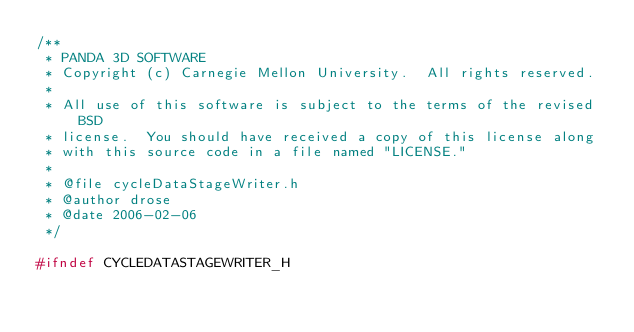<code> <loc_0><loc_0><loc_500><loc_500><_C_>/**
 * PANDA 3D SOFTWARE
 * Copyright (c) Carnegie Mellon University.  All rights reserved.
 *
 * All use of this software is subject to the terms of the revised BSD
 * license.  You should have received a copy of this license along
 * with this source code in a file named "LICENSE."
 *
 * @file cycleDataStageWriter.h
 * @author drose
 * @date 2006-02-06
 */

#ifndef CYCLEDATASTAGEWRITER_H</code> 